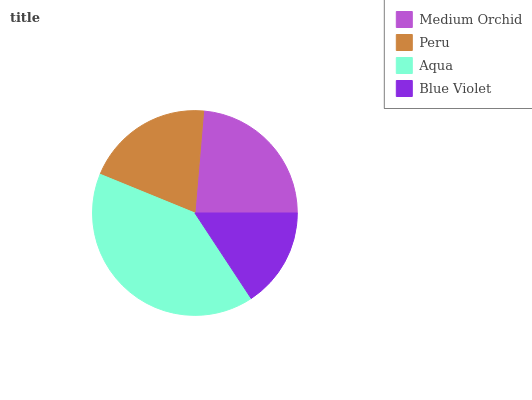Is Blue Violet the minimum?
Answer yes or no. Yes. Is Aqua the maximum?
Answer yes or no. Yes. Is Peru the minimum?
Answer yes or no. No. Is Peru the maximum?
Answer yes or no. No. Is Medium Orchid greater than Peru?
Answer yes or no. Yes. Is Peru less than Medium Orchid?
Answer yes or no. Yes. Is Peru greater than Medium Orchid?
Answer yes or no. No. Is Medium Orchid less than Peru?
Answer yes or no. No. Is Medium Orchid the high median?
Answer yes or no. Yes. Is Peru the low median?
Answer yes or no. Yes. Is Aqua the high median?
Answer yes or no. No. Is Medium Orchid the low median?
Answer yes or no. No. 